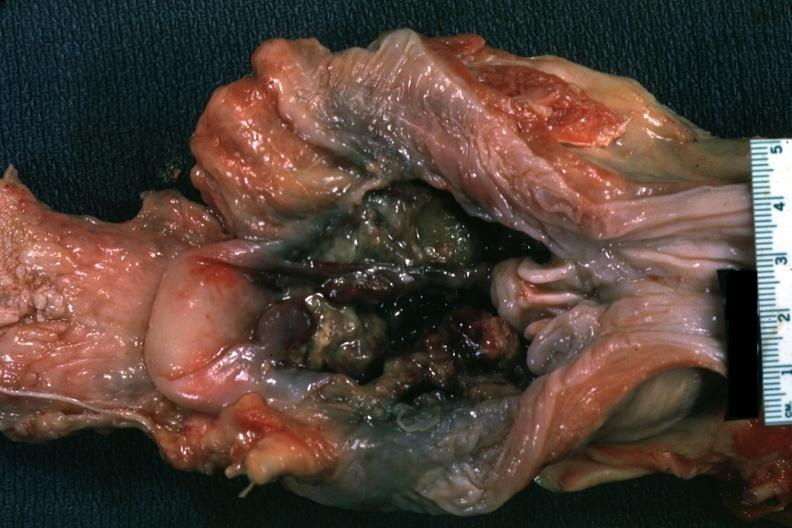what does this image show?
Answer the question using a single word or phrase. Unopened larynx viewed from hypopharynx mass of necrotic tissue 